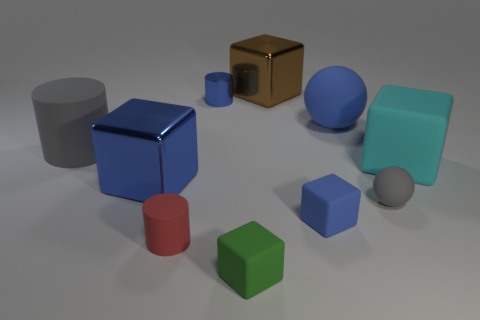What is the large block that is to the right of the green block and on the left side of the gray rubber ball made of?
Provide a short and direct response. Metal. There is a tiny thing behind the large blue metal object; is its color the same as the small matte ball?
Ensure brevity in your answer.  No. There is a shiny cylinder; is its color the same as the matte cylinder in front of the tiny gray ball?
Give a very brief answer. No. There is a large cyan cube; are there any large shiny objects on the right side of it?
Offer a very short reply. No. Does the brown block have the same material as the big cylinder?
Provide a succinct answer. No. There is a brown cube that is the same size as the blue ball; what is its material?
Keep it short and to the point. Metal. How many objects are big gray rubber things that are in front of the brown shiny thing or big brown objects?
Make the answer very short. 2. Are there an equal number of tiny red rubber objects that are in front of the brown object and green things?
Offer a very short reply. Yes. Does the tiny matte ball have the same color as the big ball?
Your answer should be very brief. No. The rubber cube that is both in front of the cyan block and to the right of the green object is what color?
Offer a terse response. Blue. 